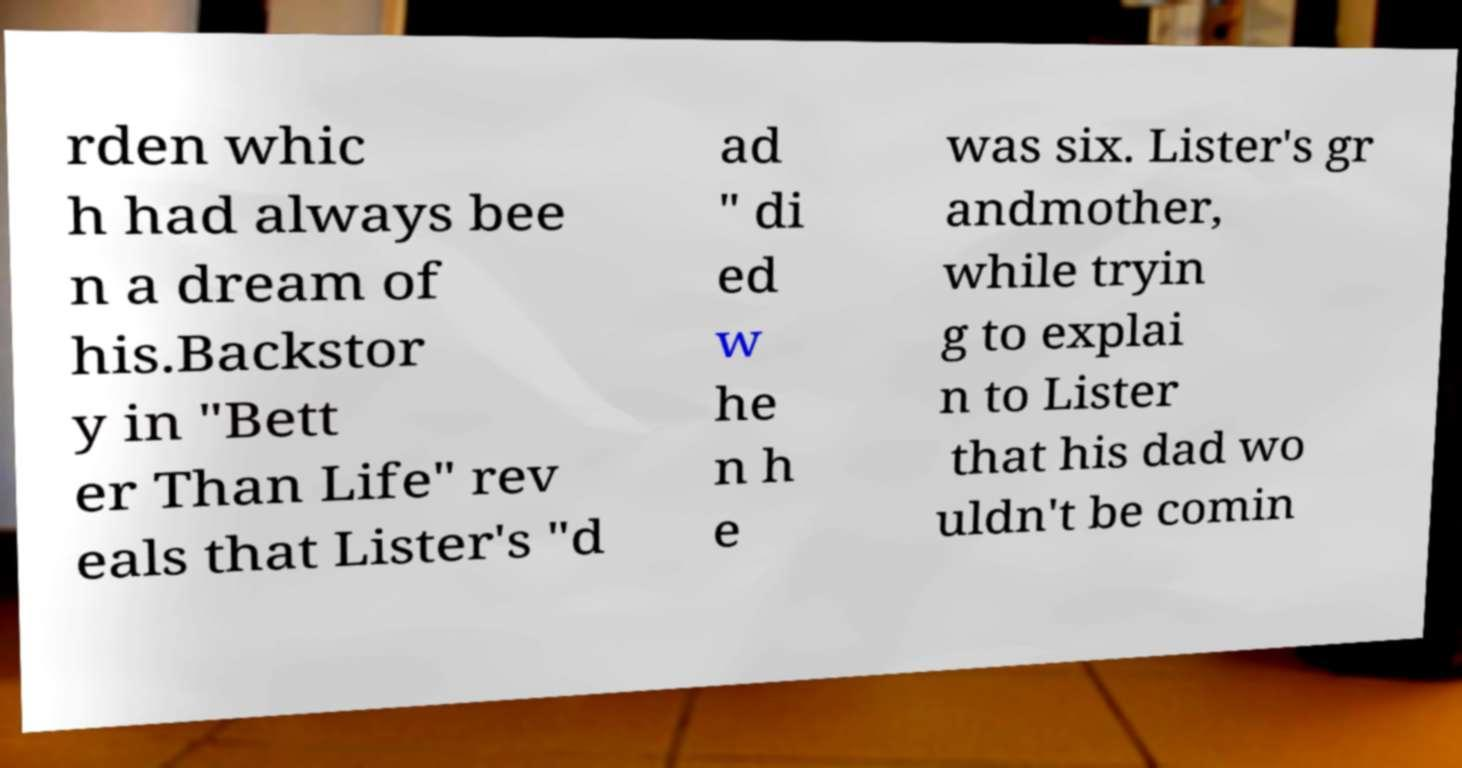There's text embedded in this image that I need extracted. Can you transcribe it verbatim? rden whic h had always bee n a dream of his.Backstor y in "Bett er Than Life" rev eals that Lister's "d ad " di ed w he n h e was six. Lister's gr andmother, while tryin g to explai n to Lister that his dad wo uldn't be comin 